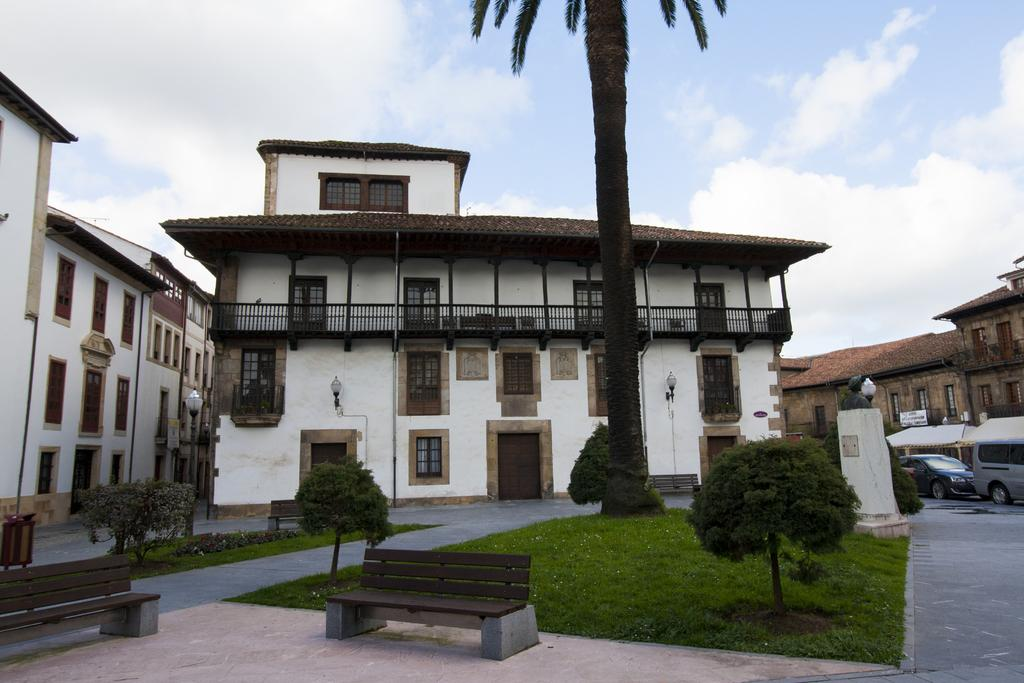What can be seen in the sky in the image? The sky with clouds is visible in the image. What type of structures are present in the image? There are buildings in the image. What architectural features can be seen in the image? There is a door and a window in the image. What type of seating is available in the image? There are benches in the image. What type of vegetation is present in the image? Plants and grass are visible in the image. What type of transportation is present in the image? Vehicles are on the road in the image. Can you see the ocean in the image? No, the ocean is not present in the image. Which eye of the person in the image is visible? There is no person in the image, so no eye is visible. 